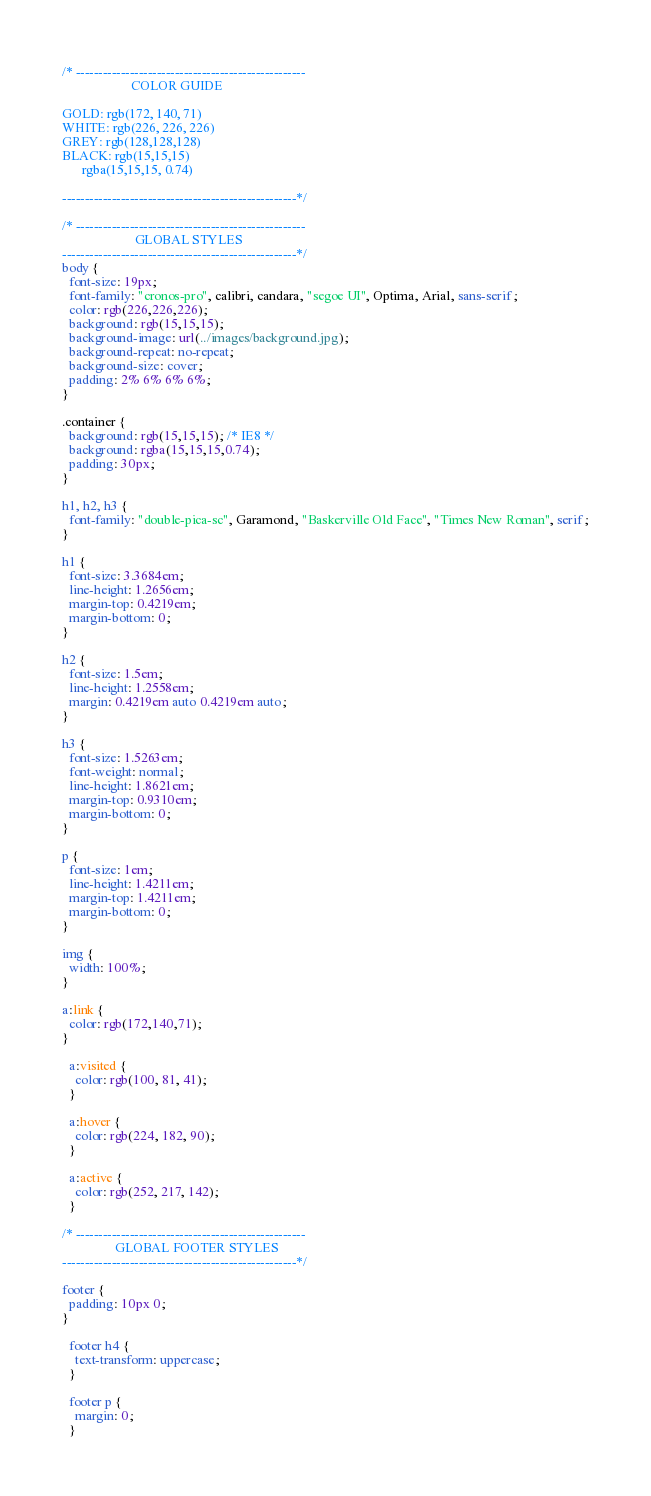<code> <loc_0><loc_0><loc_500><loc_500><_CSS_>/* ---------------------------------------------------
                     COLOR GUIDE

GOLD: rgb(172, 140, 71)
WHITE: rgb(226, 226, 226)
GREY: rgb(128,128,128)
BLACK: rgb(15,15,15)
      rgba(15,15,15, 0.74)

----------------------------------------------------*/

/* ---------------------------------------------------
                      GLOBAL STYLES
----------------------------------------------------*/
body {
  font-size: 19px;
  font-family: "cronos-pro", calibri, candara, "segoe UI", Optima, Arial, sans-serif;
  color: rgb(226,226,226);
  background: rgb(15,15,15);
  background-image: url(../images/background.jpg);
  background-repeat: no-repeat;
  background-size: cover;
  padding: 2% 6% 6% 6%;
}

.container {
  background: rgb(15,15,15); /* IE8 */
  background: rgba(15,15,15,0.74);
  padding: 30px;
}

h1, h2, h3 {
  font-family: "double-pica-sc", Garamond, "Baskerville Old Face", "Times New Roman", serif;
}

h1 {
  font-size: 3.3684em;
  line-height: 1.2656em;
  margin-top: 0.4219em;
  margin-bottom: 0;
}

h2 {
  font-size: 1.5em;
  line-height: 1.2558em;
  margin: 0.4219em auto 0.4219em auto;
}

h3 {
  font-size: 1.5263em;
  font-weight: normal;
  line-height: 1.8621em;
  margin-top: 0.9310em;
  margin-bottom: 0;
}

p {
  font-size: 1em;
  line-height: 1.4211em;
  margin-top: 1.4211em;
  margin-bottom: 0;
}

img {
  width: 100%;
}

a:link {
  color: rgb(172,140,71);
}

  a:visited {
    color: rgb(100, 81, 41);
  }

  a:hover {
    color: rgb(224, 182, 90);
  }

  a:active {
    color: rgb(252, 217, 142);
  }

/* ---------------------------------------------------
                GLOBAL FOOTER STYLES
----------------------------------------------------*/

footer {
  padding: 10px 0;
}

  footer h4 {
    text-transform: uppercase;
  }

  footer p {
    margin: 0;
  }</code> 